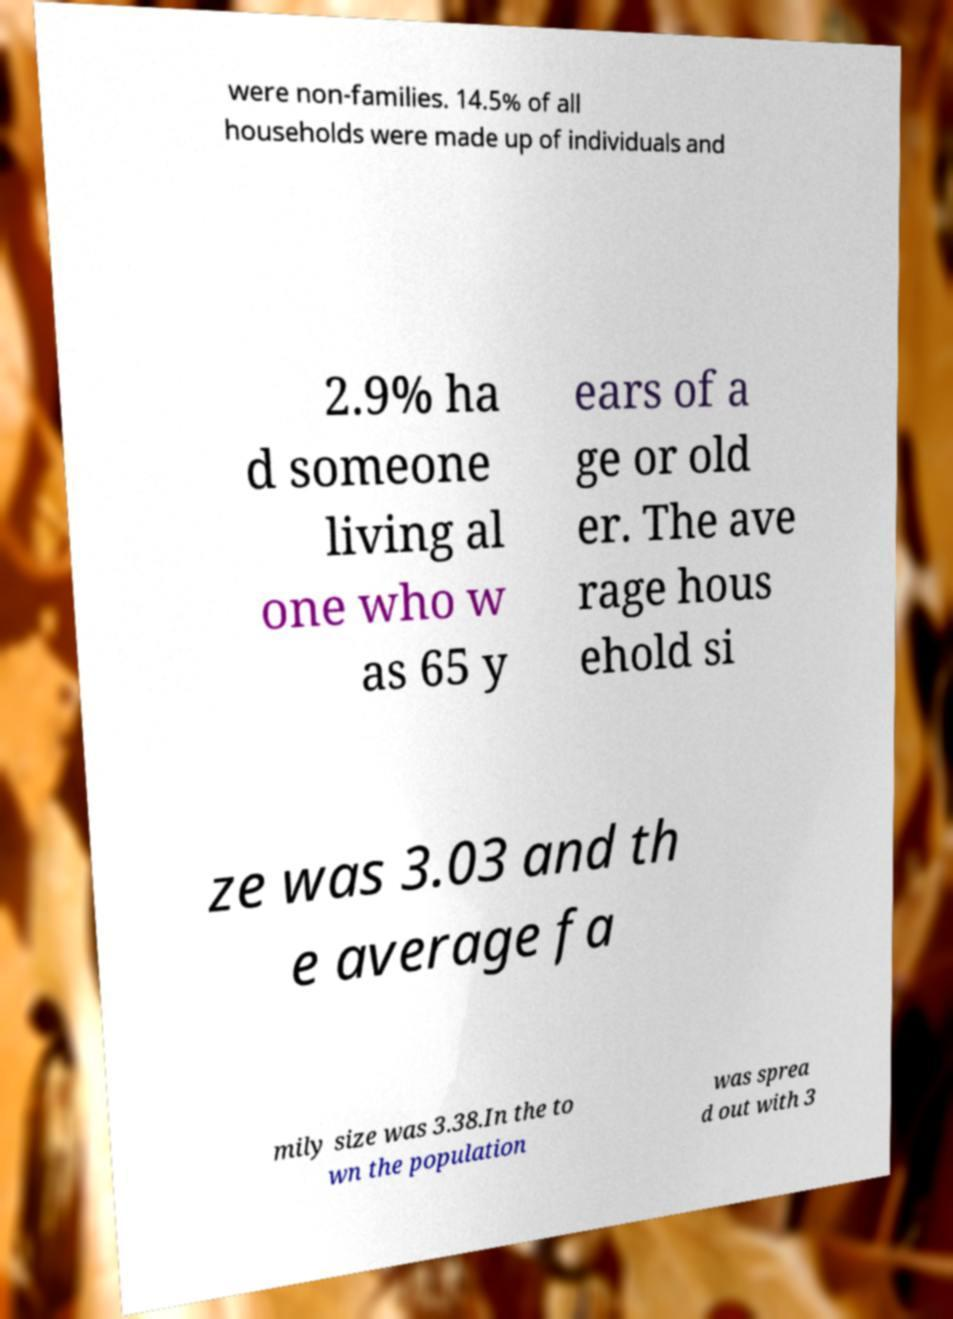Can you read and provide the text displayed in the image?This photo seems to have some interesting text. Can you extract and type it out for me? were non-families. 14.5% of all households were made up of individuals and 2.9% ha d someone living al one who w as 65 y ears of a ge or old er. The ave rage hous ehold si ze was 3.03 and th e average fa mily size was 3.38.In the to wn the population was sprea d out with 3 